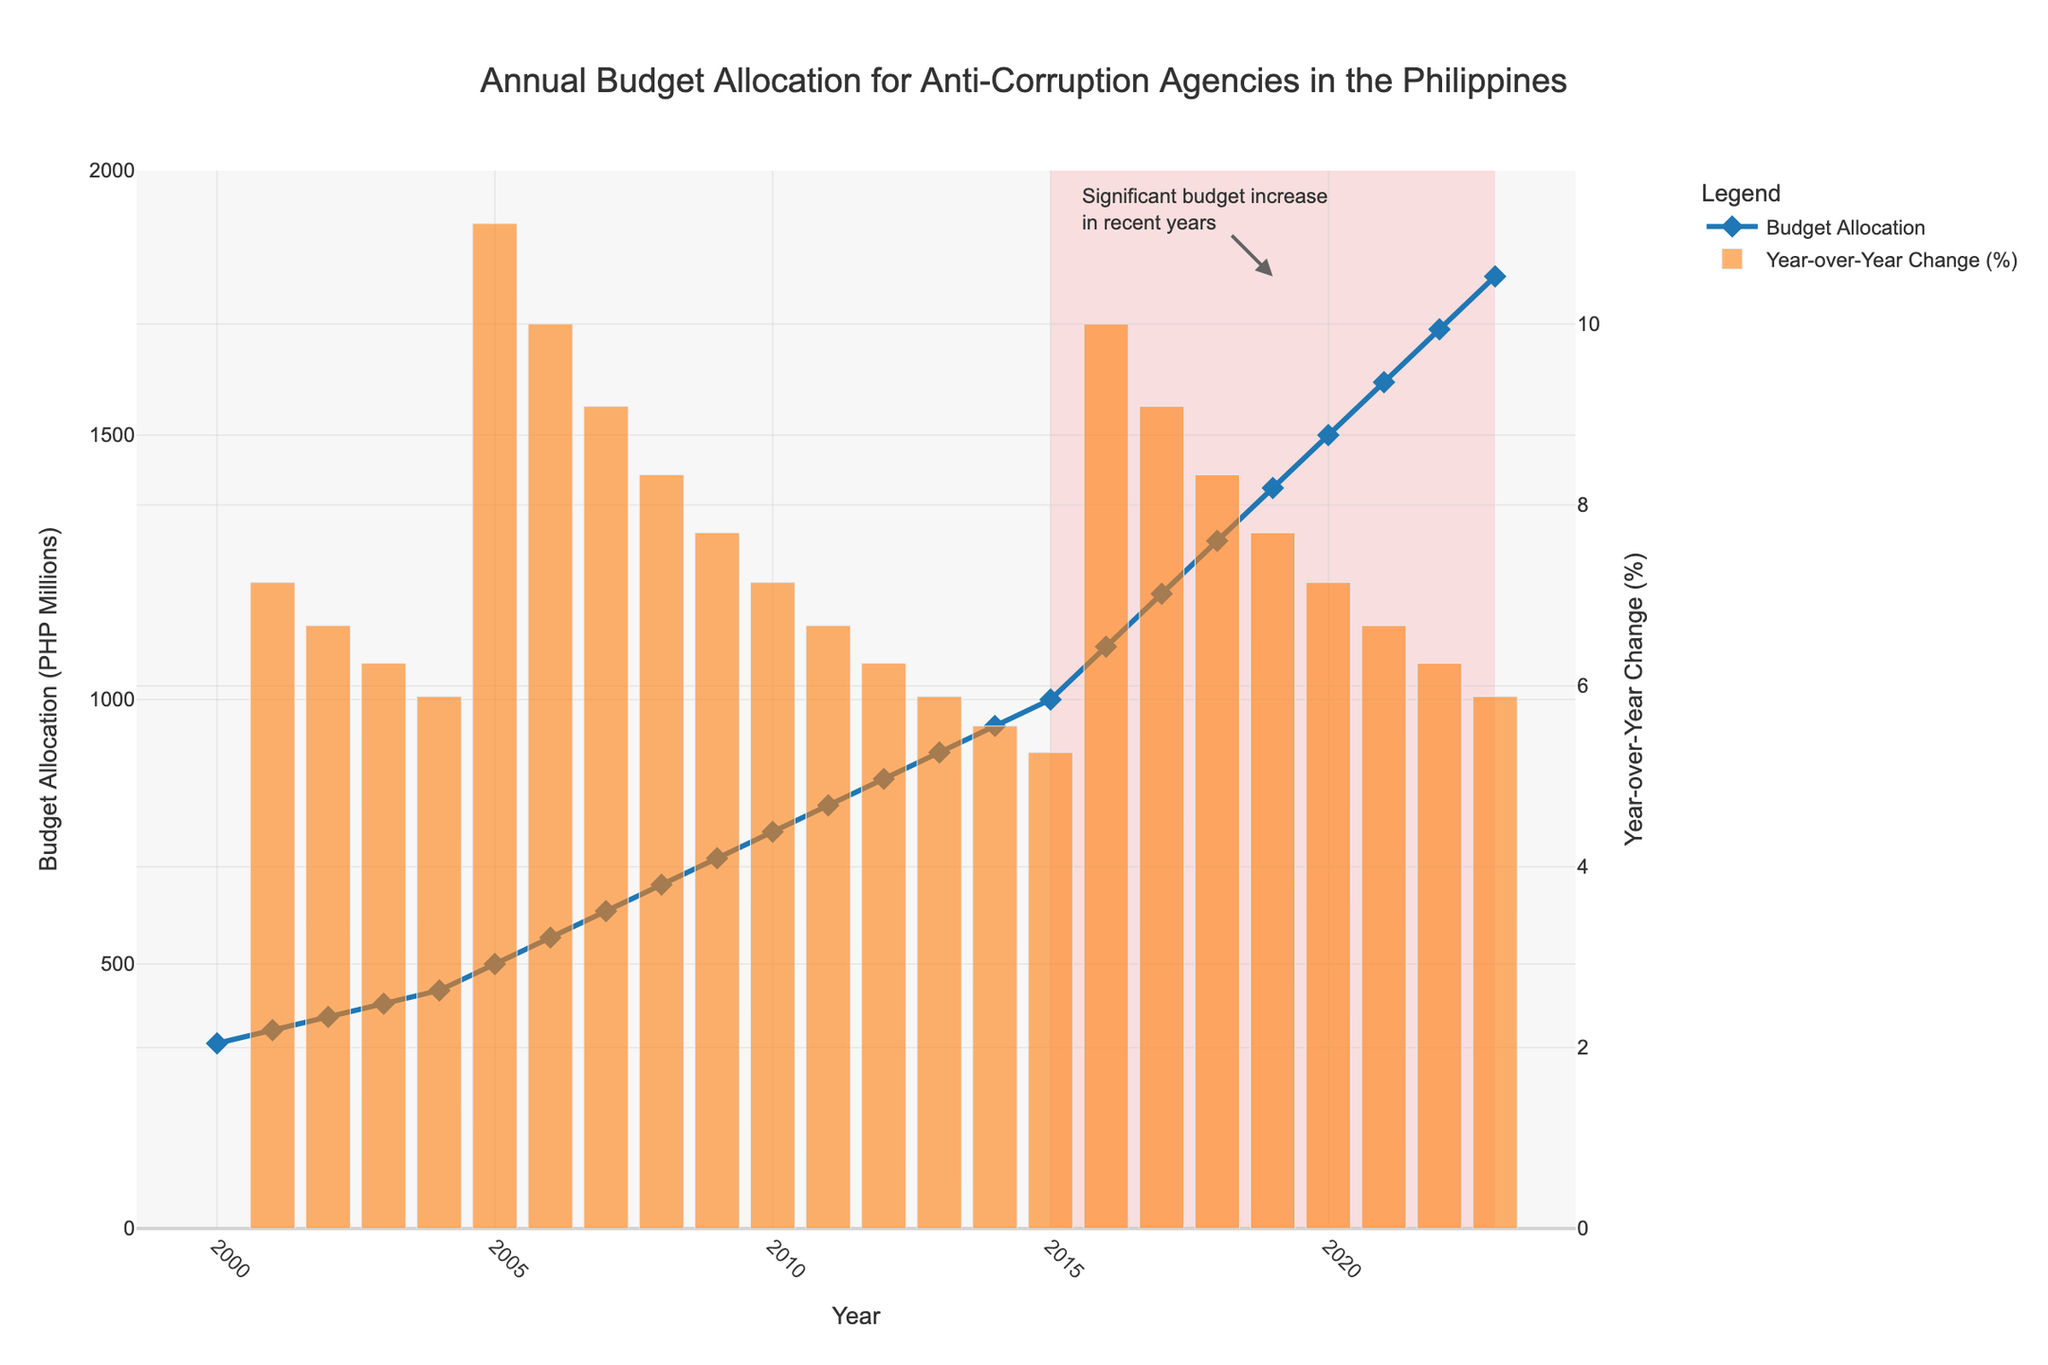What's the budget allocation for anti-corruption agencies in the year 2010? Locate the year 2010 on the x-axis and observe the corresponding y-axis value on the line chart, which shows the budget allocation.
Answer: 750 million PHP How much did the budget allocation increase from 2000 to 2023? Identify the budget value for the year 2000 (350 million PHP) and 2023 (1800 million PHP). Subtract the 2000 value from the 2023 value to find the increase: 1800 - 350
Answer: 1450 million PHP What was the year-over-year percentage change in the budget allocation in 2005? Locate the bar for 2005 and observe its height, which represents the year-over-year percentage change. The bar reaches the 11% mark.
Answer: 11% Which year had the highest budget allocation and what was the allocation amount? Observe the highest point on the line chart, which corresponds to the year at the far right (2023). The y-axis value at this point indicates the budget allocation.
Answer: 2023, 1800 million PHP Did the budget allocation ever decrease year-over-year between 2000 and 2023? Look at the bar chart for any bars that fall below the 0% line on the secondary y-axis (representing negative percentage changes). No bars fall below this line, indicating no decreases.
Answer: No How much did the budget allocation increase from 2016 to 2020? Identify the budget amounts in 2016 (1100 million PHP) and 2020 (1500 million PHP). Subtract the 2016 value from the 2020 value to find the increase: 1500 - 1100
Answer: 400 million PHP What is the median budget allocation between 2000 and 2023? List all budget allocations in ascending order. The median is the middle value in this ordered list. There are 24 values, so the median is the average of the 12th and 13th values: (850 + 900) / 2
Answer: 875 million PHP 